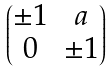<formula> <loc_0><loc_0><loc_500><loc_500>\begin{pmatrix} \pm 1 & a \\ 0 & \pm 1 \end{pmatrix}</formula> 